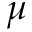Convert formula to latex. <formula><loc_0><loc_0><loc_500><loc_500>\mu</formula> 